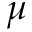Convert formula to latex. <formula><loc_0><loc_0><loc_500><loc_500>\mu</formula> 